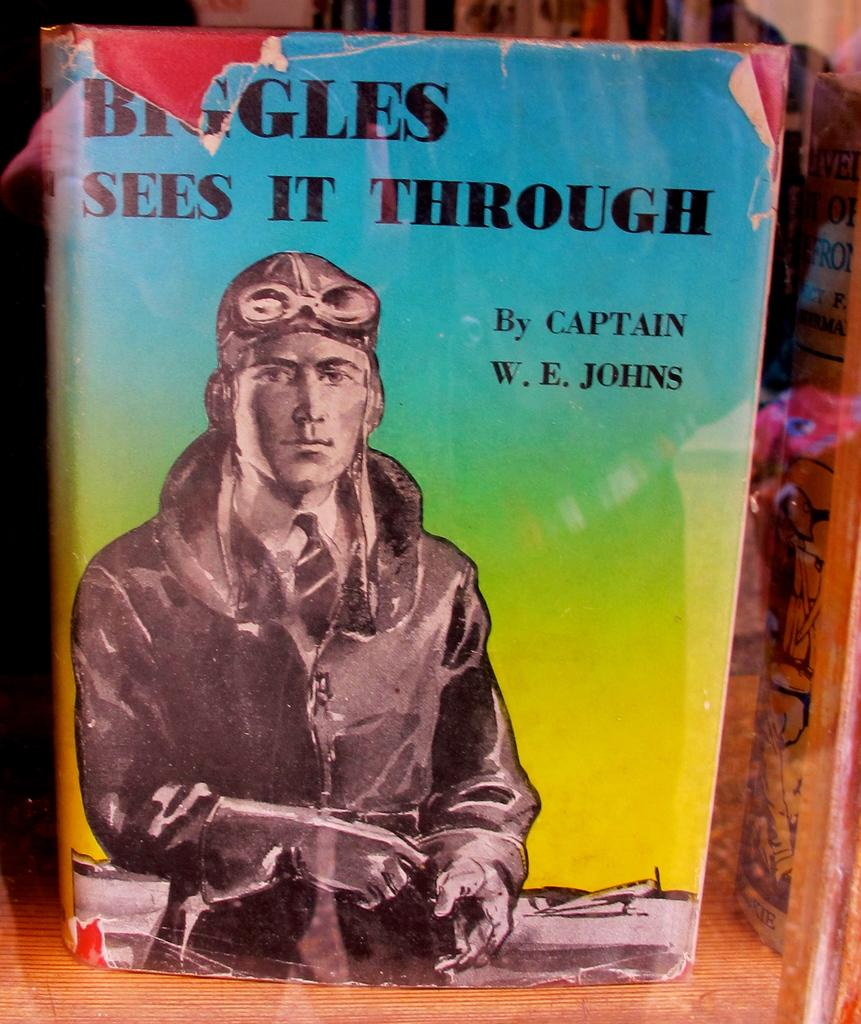Provide a one-sentence caption for the provided image. A book by Captain W. E. Johns entitled Biggles Sees It Through. 